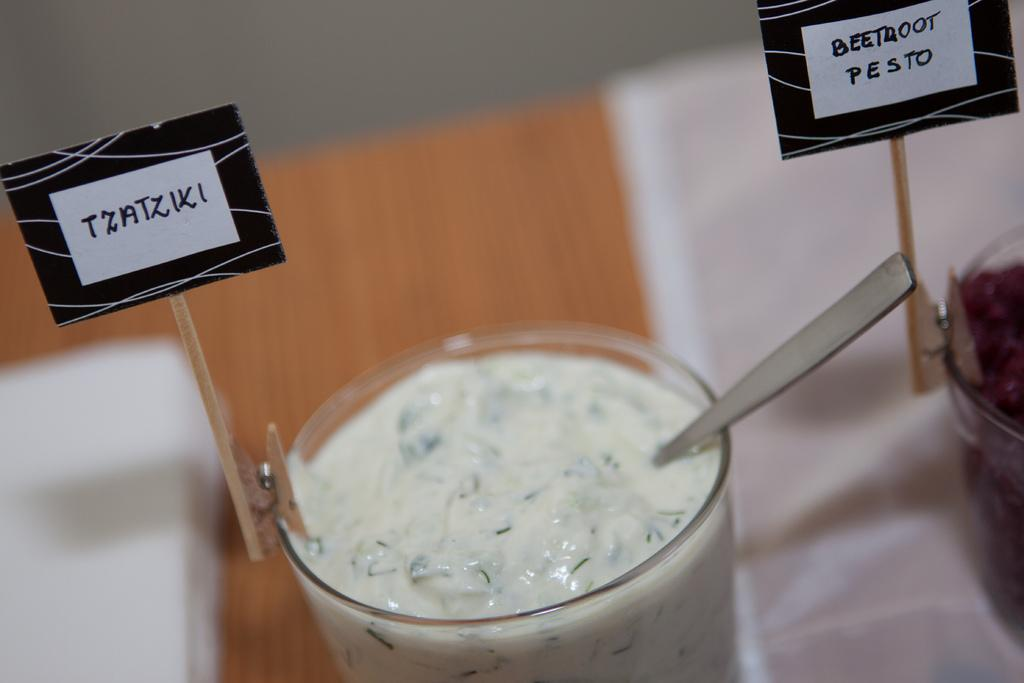What is located at the top of the image? There is a wall at the top of the image. What is in the middle of the image? There is a table in the middle of the image. What can be seen on the table? There are two glasses of desserts and spoons on the table. What else is on the table? There are two name boards on the table. What type of crayon is being used to draw on the wall in the image? There is no crayon or drawing on the wall in the image. How many eggs are visible on the table in the image? There are no eggs present on the table in the image. 